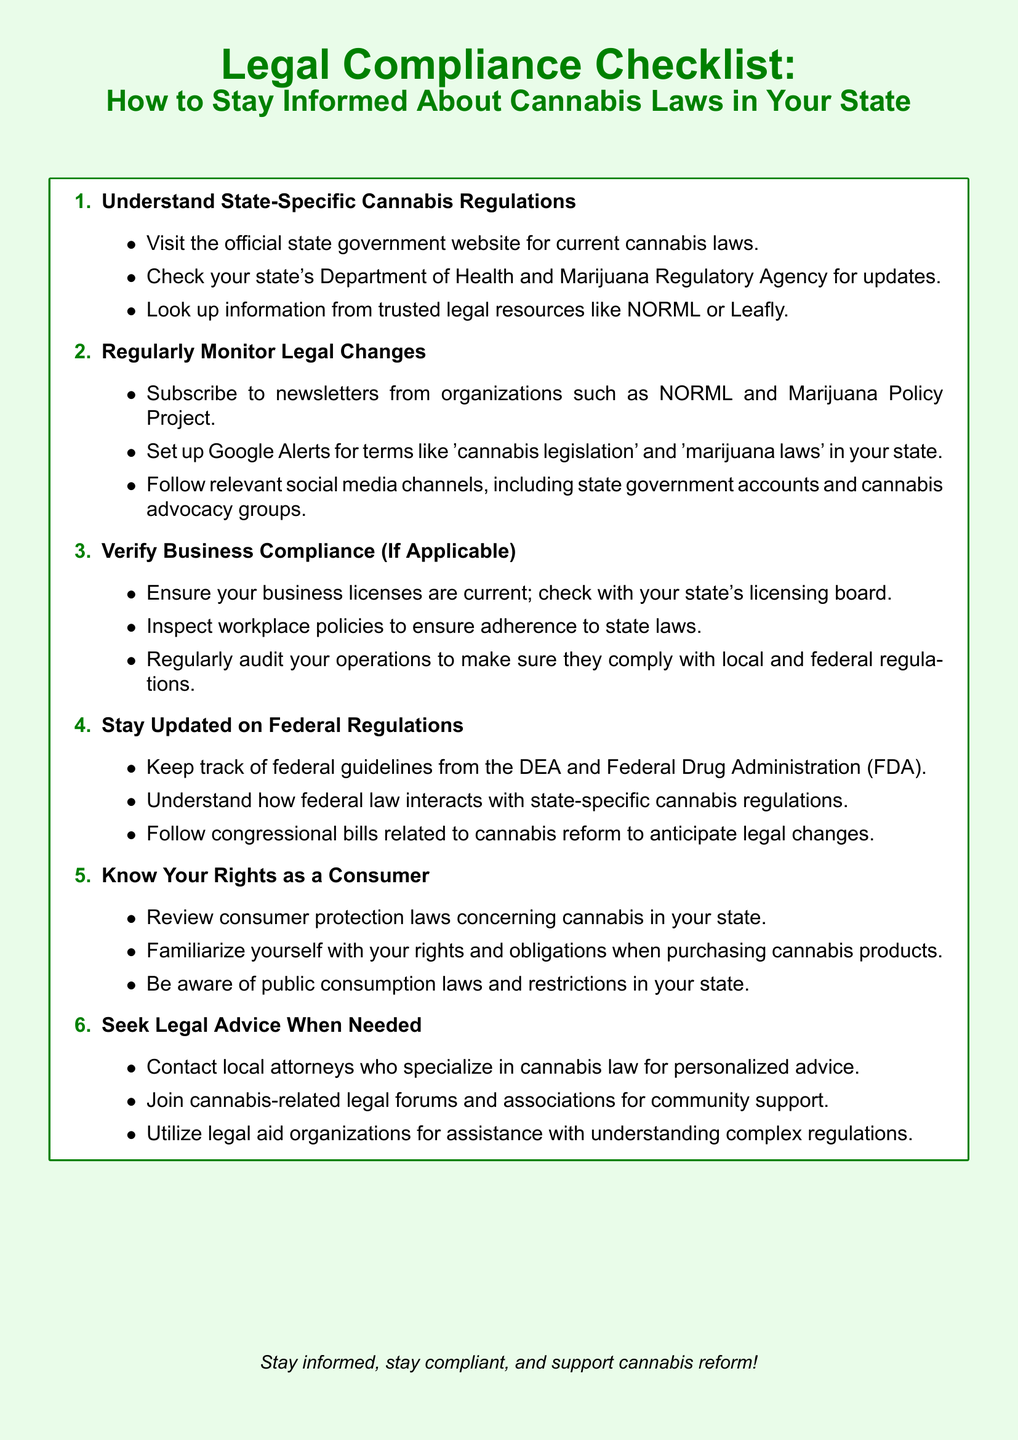What is the main title of the document? The main title presents the purpose of the document, which is about cannabis laws, specifically focused on compliance.
Answer: Legal Compliance Checklist: How to Stay Informed About Cannabis Laws in Your State How many items are in the checklist? The checklist contains a series of enumerated items that guide users in compliance with cannabis laws.
Answer: Six What is the first step in the checklist? The first step outlines the foundation of understanding cannabis regulations at the state level.
Answer: Understand State-Specific Cannabis Regulations Which organization's newsletters should you subscribe to for updates? The document mentions specific organizations that provide valuable updates on cannabis legislation and policies.
Answer: NORML What is one way to monitor legal changes? The checklist suggests practical steps to keep informed about evolving cannabis laws.
Answer: Set up Google Alerts Which federal agency's guidelines should be monitored? The document highlights a significant federal agency concerned with drug regulation and enforcement in the United States.
Answer: DEA What should you do to verify business compliance? This question relates to ensuring that a business abides by the legal requirements as outlined in the checklist.
Answer: Ensure your business licenses are current Who can be contacted for personalized legal advice? The document encourages seeking expertise from professionals in cannabis law for specific situations.
Answer: Local attorneys What is the last piece of advice in the checklist? This question asks for the concluding message that emphasizes the importance of staying informed and compliant.
Answer: Stay informed, stay compliant, and support cannabis reform! 